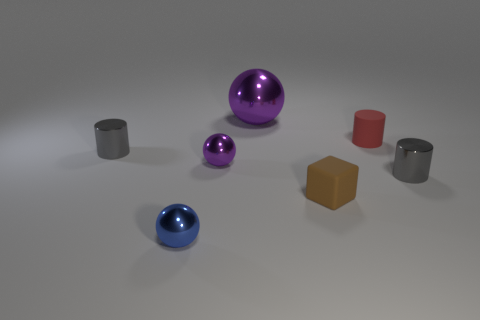What is the texture of the purple ball, and does it affect how light interacts with it? The purple ball has a glossy texture, which gives it a highly reflective surface. This affects how light interacts with it by creating strong highlights and defined reflections, making it appear shiny and smooth. 